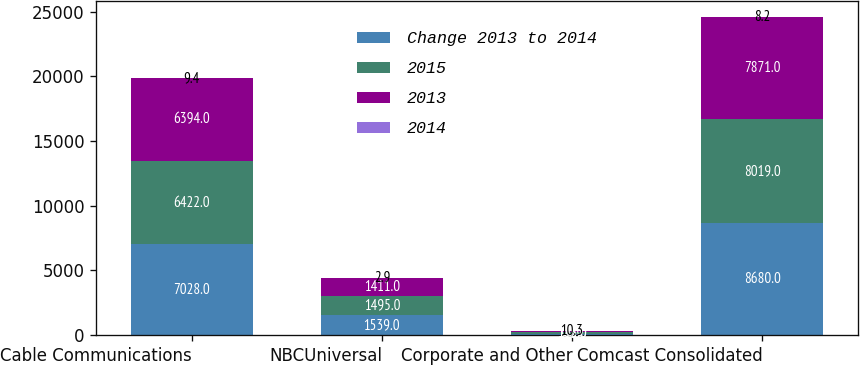Convert chart. <chart><loc_0><loc_0><loc_500><loc_500><stacked_bar_chart><ecel><fcel>Cable Communications<fcel>NBCUniversal<fcel>Corporate and Other<fcel>Comcast Consolidated<nl><fcel>Change 2013 to 2014<fcel>7028<fcel>1539<fcel>113<fcel>8680<nl><fcel>2015<fcel>6422<fcel>1495<fcel>102<fcel>8019<nl><fcel>2013<fcel>6394<fcel>1411<fcel>66<fcel>7871<nl><fcel>2014<fcel>9.4<fcel>2.9<fcel>10.3<fcel>8.2<nl></chart> 